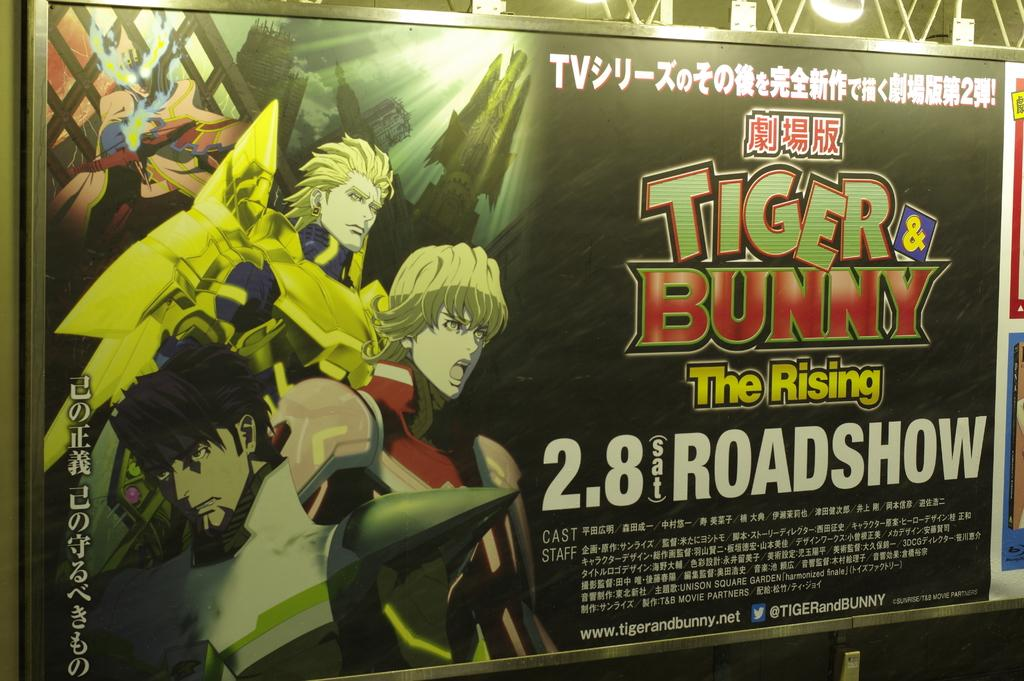Provide a one-sentence caption for the provided image. Poster for an anime titled "Tiger & Bunny". 